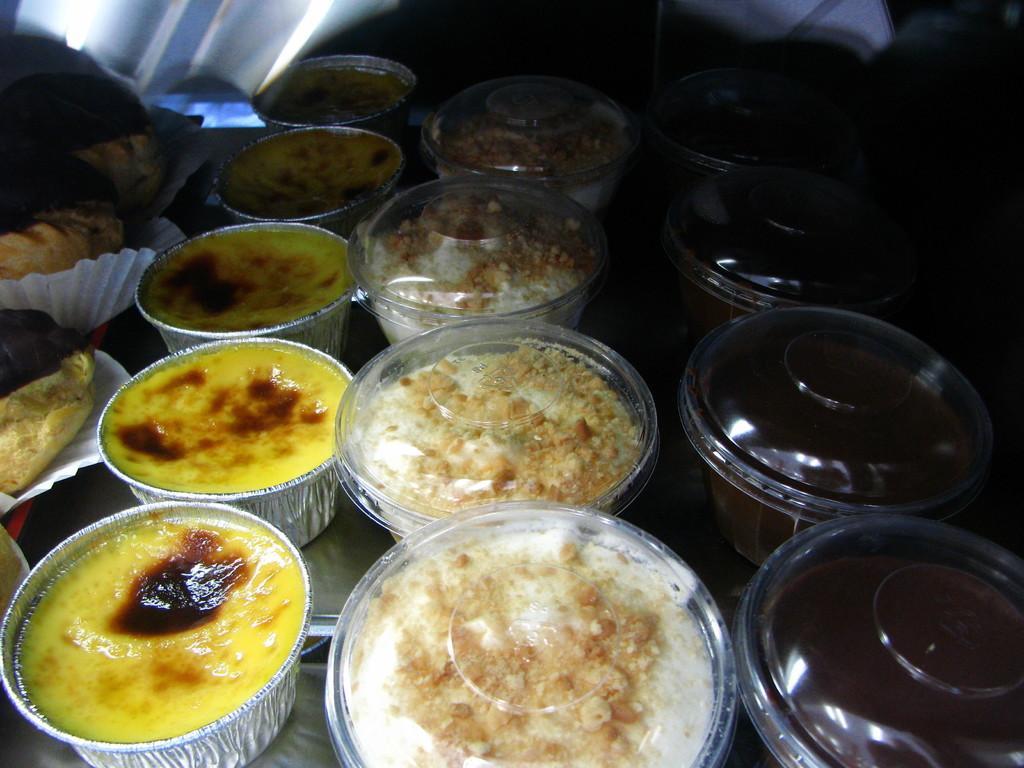How would you summarize this image in a sentence or two? In this image I can see few bowls with food items in them. I can see the dark background. 